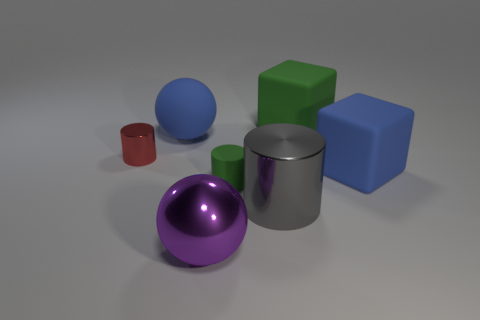There is a matte thing left of the big purple ball; what size is it? The matte object to the left of the big purple ball is a gray cylinder, which appears to be medium-sized in relation to the other objects in the image. 